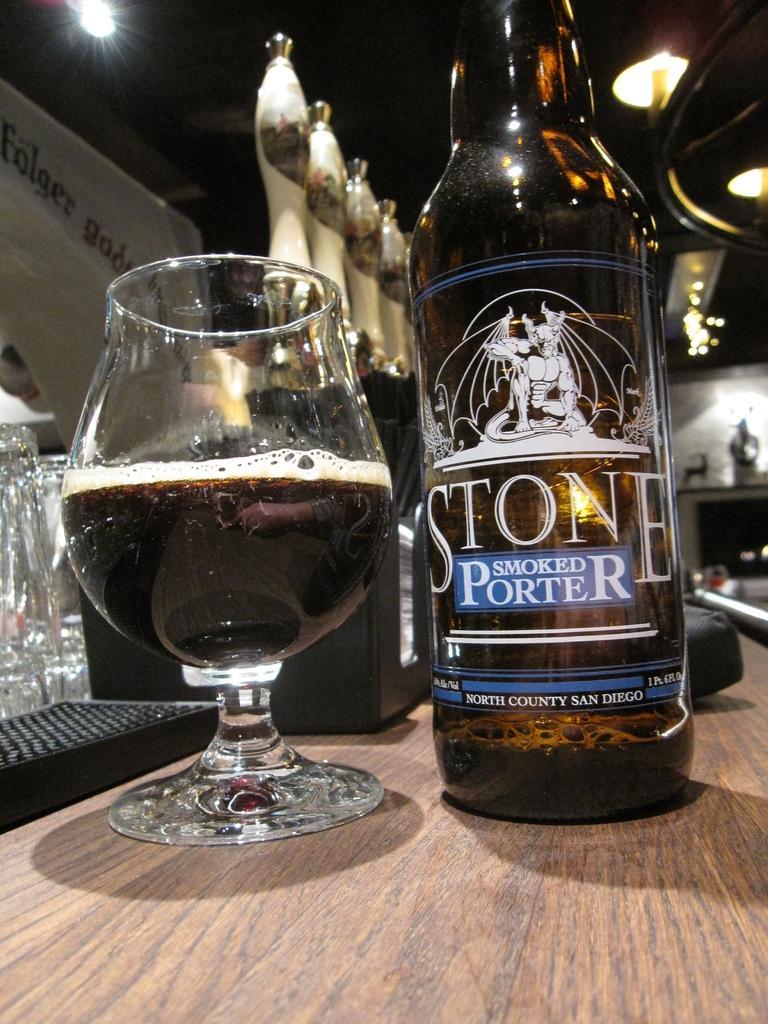Please provide a concise description of this image. In the image there is a black color bottle, to the left side there is a glass and some drink inside the bottle, in the background there are few other things, these are placed on a table to the left side there is a white color banner and above it there is a light. 